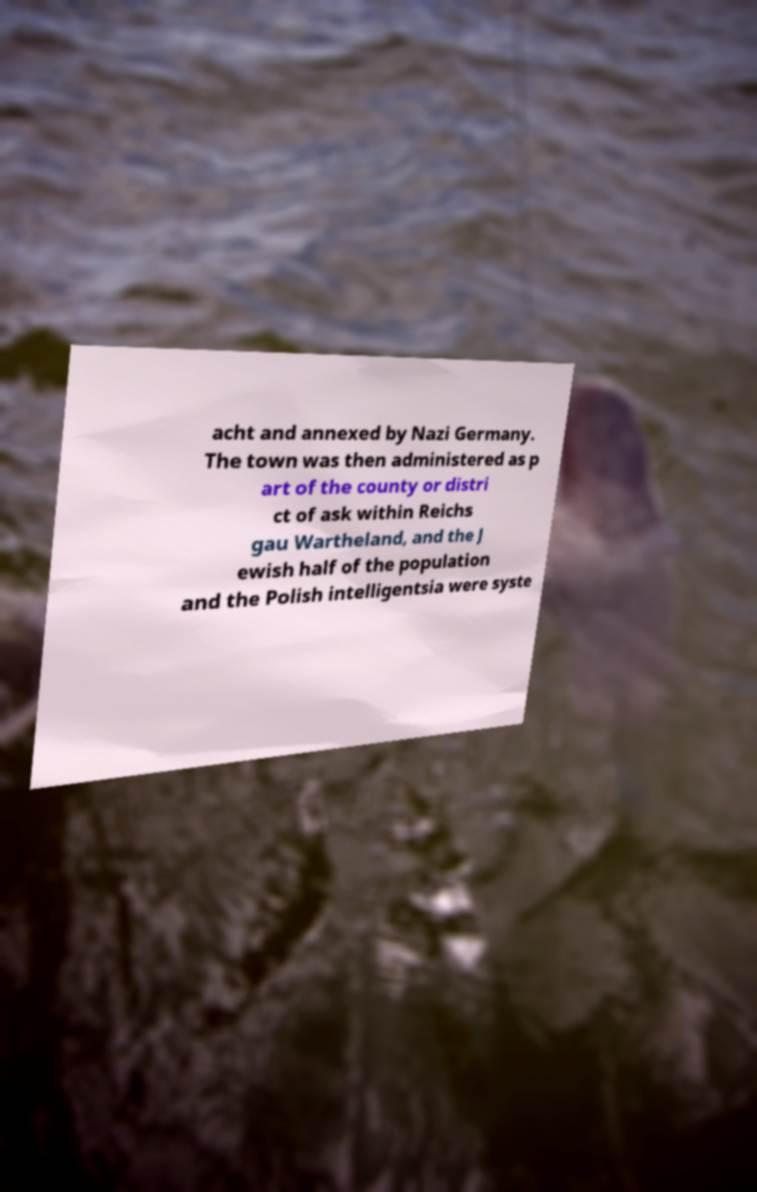I need the written content from this picture converted into text. Can you do that? acht and annexed by Nazi Germany. The town was then administered as p art of the county or distri ct of ask within Reichs gau Wartheland, and the J ewish half of the population and the Polish intelligentsia were syste 